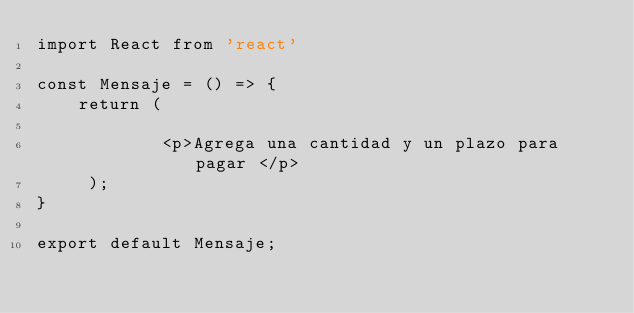<code> <loc_0><loc_0><loc_500><loc_500><_JavaScript_>import React from 'react'

const Mensaje = () => {
    return ( 

            <p>Agrega una cantidad y un plazo para pagar </p>
     );
}
 
export default Mensaje;</code> 